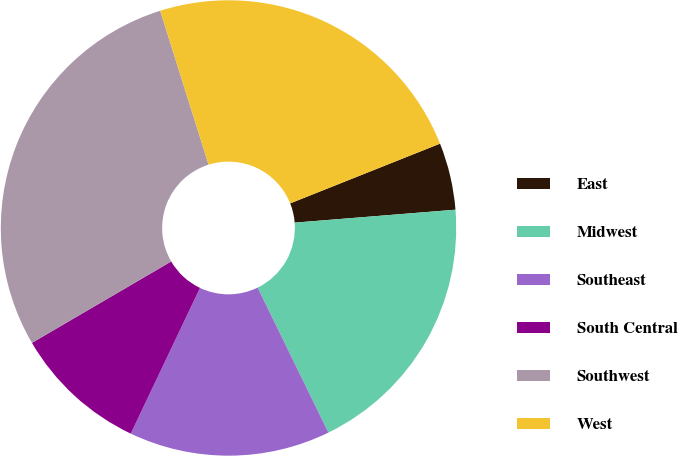Convert chart to OTSL. <chart><loc_0><loc_0><loc_500><loc_500><pie_chart><fcel>East<fcel>Midwest<fcel>Southeast<fcel>South Central<fcel>Southwest<fcel>West<nl><fcel>4.76%<fcel>19.05%<fcel>14.29%<fcel>9.52%<fcel>28.57%<fcel>23.81%<nl></chart> 